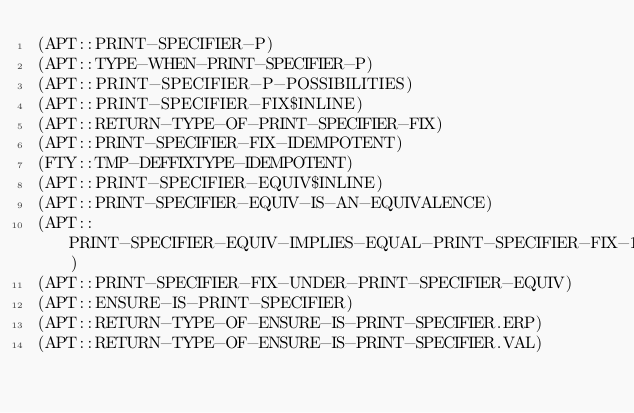Convert code to text. <code><loc_0><loc_0><loc_500><loc_500><_Lisp_>(APT::PRINT-SPECIFIER-P)
(APT::TYPE-WHEN-PRINT-SPECIFIER-P)
(APT::PRINT-SPECIFIER-P-POSSIBILITIES)
(APT::PRINT-SPECIFIER-FIX$INLINE)
(APT::RETURN-TYPE-OF-PRINT-SPECIFIER-FIX)
(APT::PRINT-SPECIFIER-FIX-IDEMPOTENT)
(FTY::TMP-DEFFIXTYPE-IDEMPOTENT)
(APT::PRINT-SPECIFIER-EQUIV$INLINE)
(APT::PRINT-SPECIFIER-EQUIV-IS-AN-EQUIVALENCE)
(APT::PRINT-SPECIFIER-EQUIV-IMPLIES-EQUAL-PRINT-SPECIFIER-FIX-1)
(APT::PRINT-SPECIFIER-FIX-UNDER-PRINT-SPECIFIER-EQUIV)
(APT::ENSURE-IS-PRINT-SPECIFIER)
(APT::RETURN-TYPE-OF-ENSURE-IS-PRINT-SPECIFIER.ERP)
(APT::RETURN-TYPE-OF-ENSURE-IS-PRINT-SPECIFIER.VAL)
</code> 